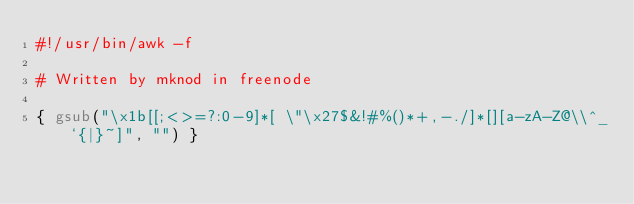Convert code to text. <code><loc_0><loc_0><loc_500><loc_500><_Awk_>#!/usr/bin/awk -f

# Written by mknod in freenode

{ gsub("\x1b[[;<>=?:0-9]*[ \"\x27$&!#%()*+,-./]*[][a-zA-Z@\\^_`{|}~]", "") }
</code> 